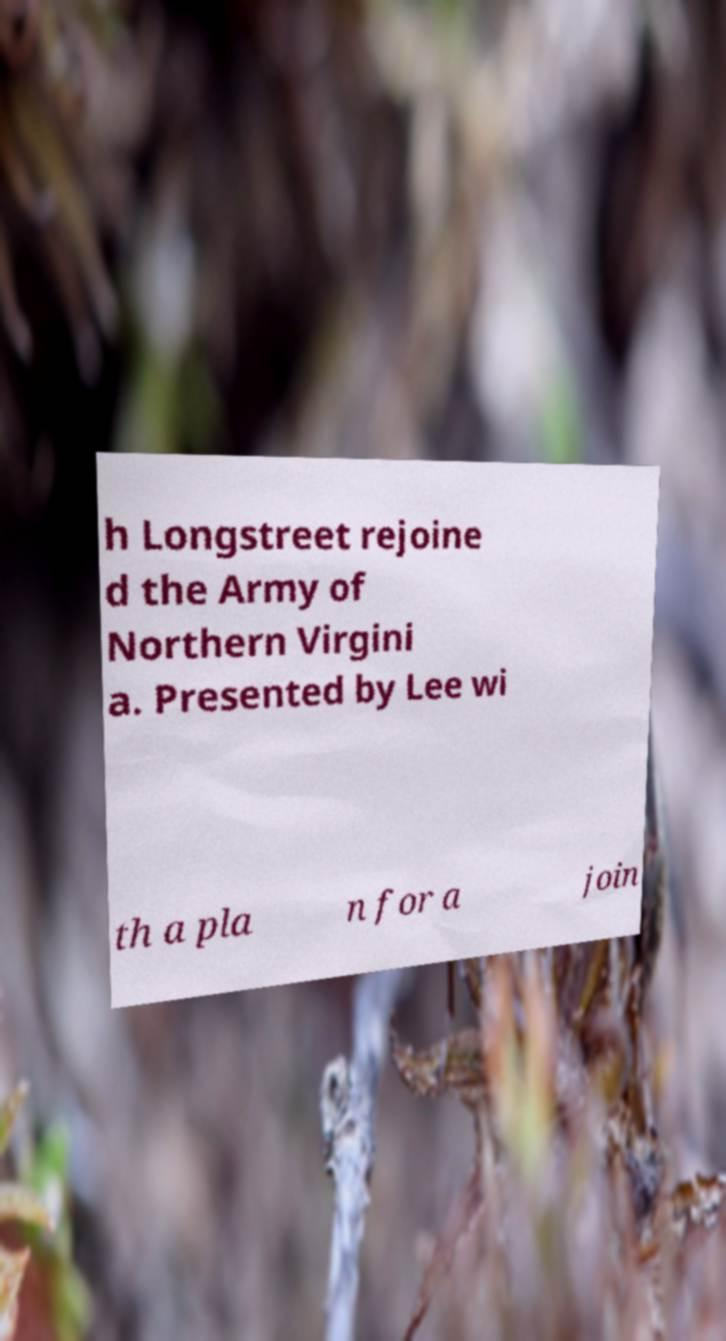What messages or text are displayed in this image? I need them in a readable, typed format. h Longstreet rejoine d the Army of Northern Virgini a. Presented by Lee wi th a pla n for a join 